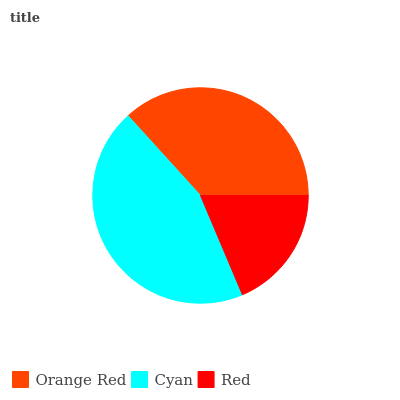Is Red the minimum?
Answer yes or no. Yes. Is Cyan the maximum?
Answer yes or no. Yes. Is Cyan the minimum?
Answer yes or no. No. Is Red the maximum?
Answer yes or no. No. Is Cyan greater than Red?
Answer yes or no. Yes. Is Red less than Cyan?
Answer yes or no. Yes. Is Red greater than Cyan?
Answer yes or no. No. Is Cyan less than Red?
Answer yes or no. No. Is Orange Red the high median?
Answer yes or no. Yes. Is Orange Red the low median?
Answer yes or no. Yes. Is Red the high median?
Answer yes or no. No. Is Red the low median?
Answer yes or no. No. 